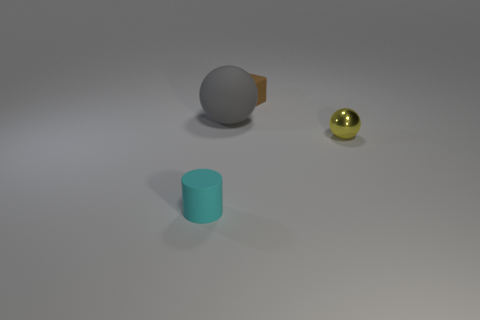What number of tiny cylinders have the same color as the metallic sphere?
Keep it short and to the point. 0. There is a rubber cylinder to the left of the cube; does it have the same size as the small yellow metallic thing?
Make the answer very short. Yes. There is a rubber thing that is both to the left of the small brown matte object and behind the shiny thing; what is its color?
Keep it short and to the point. Gray. What number of objects are large gray balls or tiny objects that are behind the cyan object?
Give a very brief answer. 3. What is the material of the small object left of the tiny thing behind the object on the right side of the brown rubber object?
Offer a very short reply. Rubber. Are there any other things that have the same material as the tiny ball?
Your response must be concise. No. Is the color of the object that is to the right of the tiny brown block the same as the cylinder?
Offer a terse response. No. How many cyan objects are either matte objects or tiny matte cylinders?
Give a very brief answer. 1. What number of other things are the same shape as the small brown matte thing?
Offer a terse response. 0. Does the big sphere have the same material as the brown cube?
Offer a terse response. Yes. 